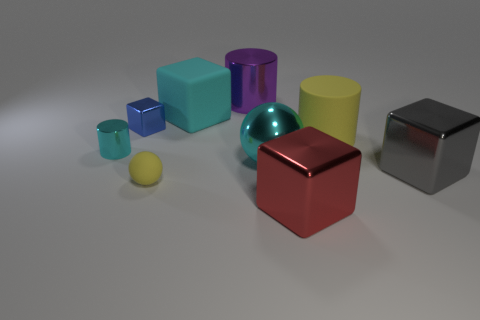Is the big metal ball the same color as the large shiny cylinder?
Provide a succinct answer. No. Is there anything else of the same color as the small metal block?
Make the answer very short. No. What color is the large ball?
Offer a terse response. Cyan. There is a rubber sphere; is its color the same as the small thing left of the tiny blue thing?
Your answer should be compact. No. There is a big matte object left of the cyan metallic sphere; is its color the same as the large metallic cylinder?
Your answer should be very brief. No. There is a big cyan cube on the right side of the tiny cube; what is it made of?
Offer a very short reply. Rubber. The other tiny cube that is made of the same material as the gray cube is what color?
Provide a succinct answer. Blue. Do the cyan matte thing and the cyan metal thing that is left of the large cyan shiny sphere have the same shape?
Ensure brevity in your answer.  No. There is a small cylinder; are there any big yellow cylinders in front of it?
Keep it short and to the point. No. There is a cylinder that is the same color as the rubber block; what is it made of?
Offer a terse response. Metal. 